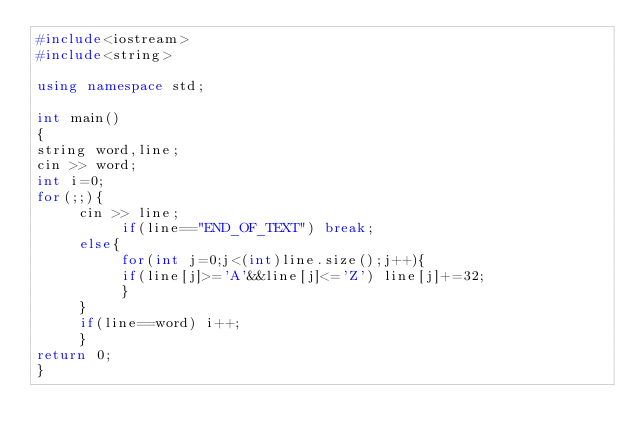Convert code to text. <code><loc_0><loc_0><loc_500><loc_500><_C++_>#include<iostream>
#include<string>

using namespace std;

int main()
{
string word,line;
cin >> word;
int i=0;
for(;;){
     cin >> line;
          if(line=="END_OF_TEXT") break;
     else{
          for(int j=0;j<(int)line.size();j++){
          if(line[j]>='A'&&line[j]<='Z') line[j]+=32;
          }
     }
     if(line==word) i++;
     }
return 0;
}
</code> 